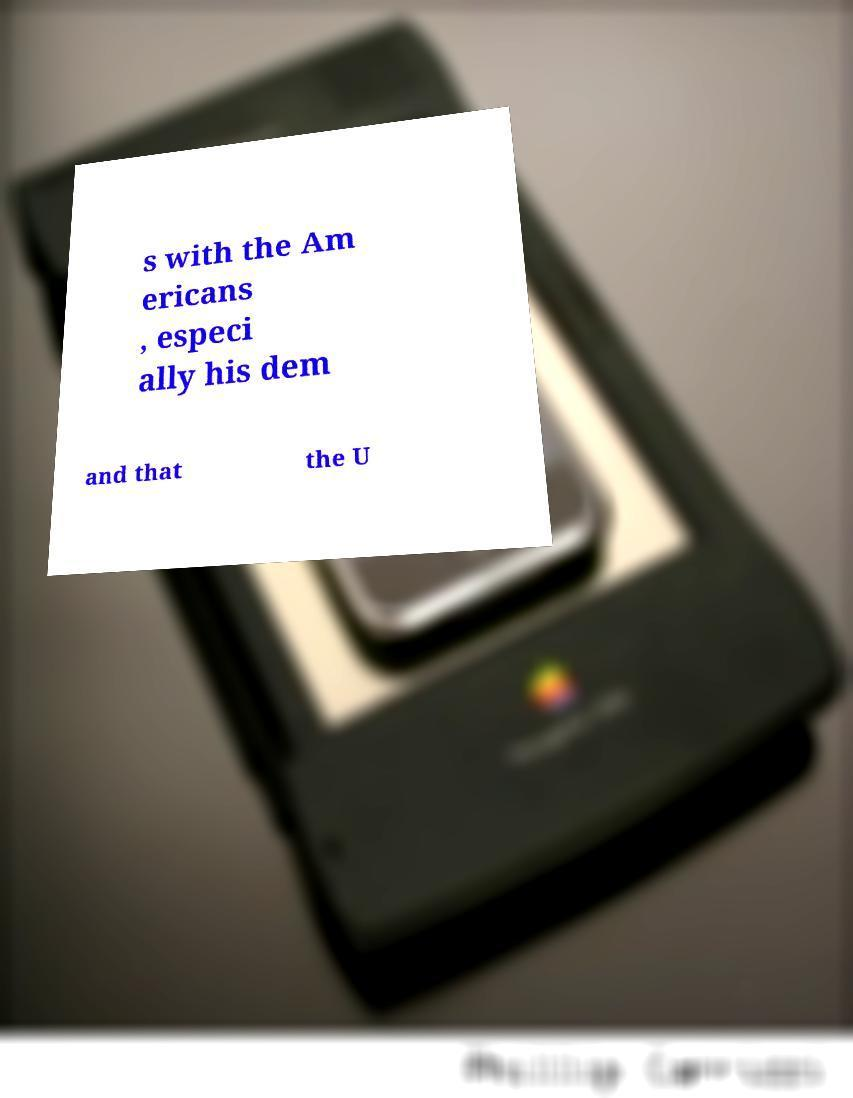For documentation purposes, I need the text within this image transcribed. Could you provide that? s with the Am ericans , especi ally his dem and that the U 